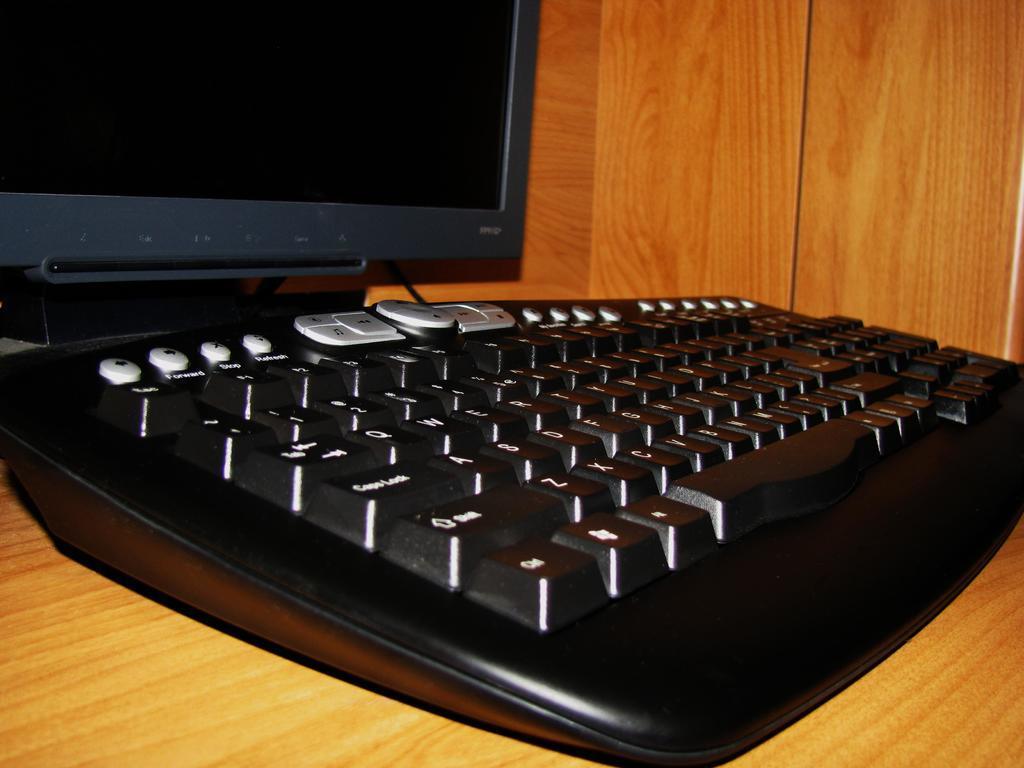Can you describe this image briefly? In this image i can see a keyboard, a desktop on a table. 